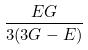<formula> <loc_0><loc_0><loc_500><loc_500>\frac { E G } { 3 ( 3 G - E ) }</formula> 